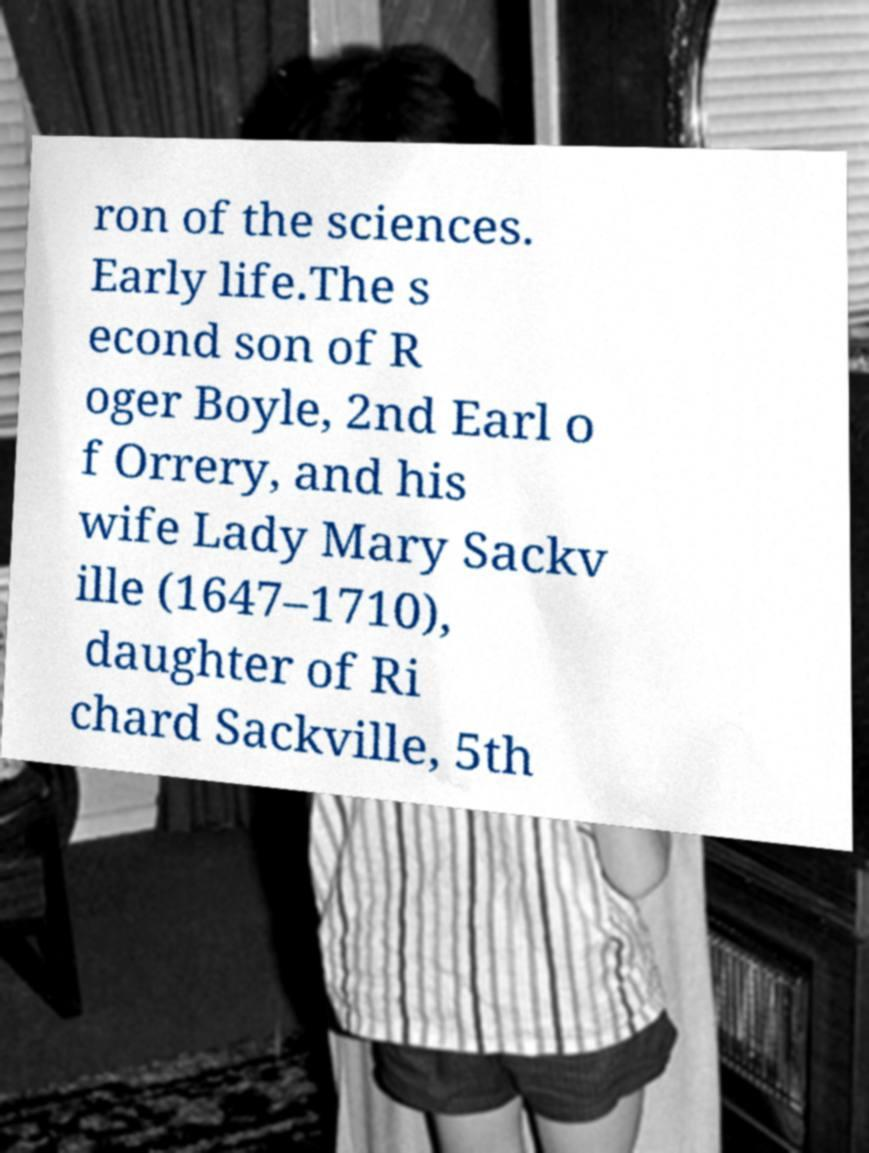Could you extract and type out the text from this image? ron of the sciences. Early life.The s econd son of R oger Boyle, 2nd Earl o f Orrery, and his wife Lady Mary Sackv ille (1647–1710), daughter of Ri chard Sackville, 5th 